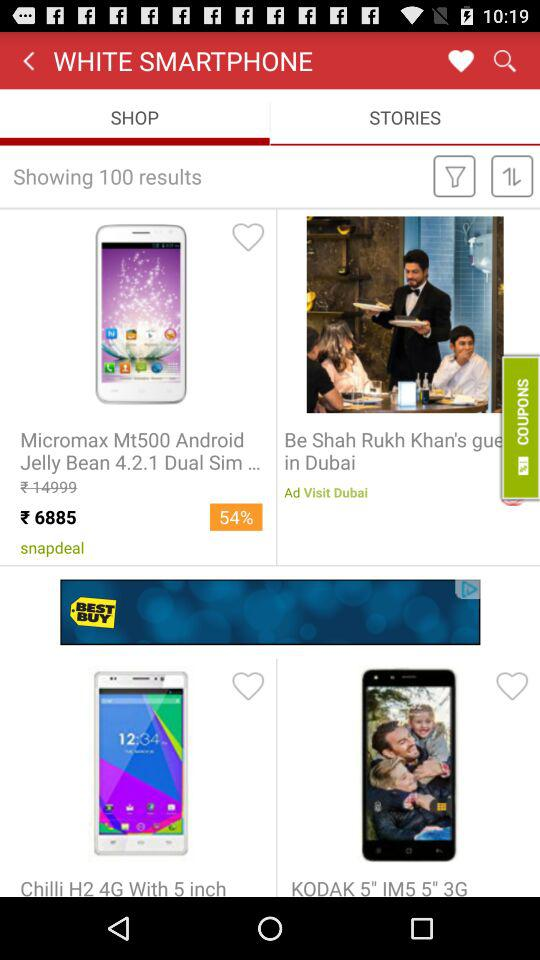What tab is selected? The selected tab is "SHOP". 